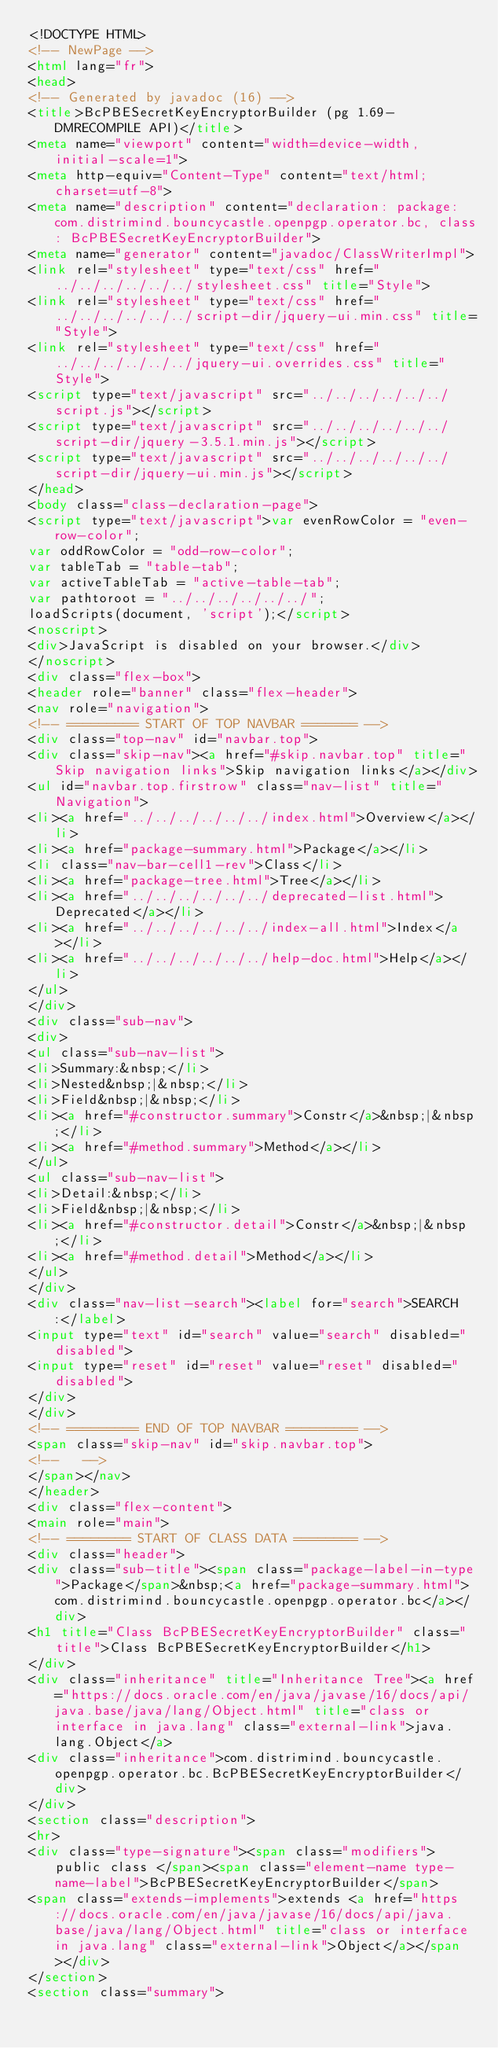<code> <loc_0><loc_0><loc_500><loc_500><_HTML_><!DOCTYPE HTML>
<!-- NewPage -->
<html lang="fr">
<head>
<!-- Generated by javadoc (16) -->
<title>BcPBESecretKeyEncryptorBuilder (pg 1.69-DMRECOMPILE API)</title>
<meta name="viewport" content="width=device-width, initial-scale=1">
<meta http-equiv="Content-Type" content="text/html; charset=utf-8">
<meta name="description" content="declaration: package: com.distrimind.bouncycastle.openpgp.operator.bc, class: BcPBESecretKeyEncryptorBuilder">
<meta name="generator" content="javadoc/ClassWriterImpl">
<link rel="stylesheet" type="text/css" href="../../../../../../stylesheet.css" title="Style">
<link rel="stylesheet" type="text/css" href="../../../../../../script-dir/jquery-ui.min.css" title="Style">
<link rel="stylesheet" type="text/css" href="../../../../../../jquery-ui.overrides.css" title="Style">
<script type="text/javascript" src="../../../../../../script.js"></script>
<script type="text/javascript" src="../../../../../../script-dir/jquery-3.5.1.min.js"></script>
<script type="text/javascript" src="../../../../../../script-dir/jquery-ui.min.js"></script>
</head>
<body class="class-declaration-page">
<script type="text/javascript">var evenRowColor = "even-row-color";
var oddRowColor = "odd-row-color";
var tableTab = "table-tab";
var activeTableTab = "active-table-tab";
var pathtoroot = "../../../../../../";
loadScripts(document, 'script');</script>
<noscript>
<div>JavaScript is disabled on your browser.</div>
</noscript>
<div class="flex-box">
<header role="banner" class="flex-header">
<nav role="navigation">
<!-- ========= START OF TOP NAVBAR ======= -->
<div class="top-nav" id="navbar.top">
<div class="skip-nav"><a href="#skip.navbar.top" title="Skip navigation links">Skip navigation links</a></div>
<ul id="navbar.top.firstrow" class="nav-list" title="Navigation">
<li><a href="../../../../../../index.html">Overview</a></li>
<li><a href="package-summary.html">Package</a></li>
<li class="nav-bar-cell1-rev">Class</li>
<li><a href="package-tree.html">Tree</a></li>
<li><a href="../../../../../../deprecated-list.html">Deprecated</a></li>
<li><a href="../../../../../../index-all.html">Index</a></li>
<li><a href="../../../../../../help-doc.html">Help</a></li>
</ul>
</div>
<div class="sub-nav">
<div>
<ul class="sub-nav-list">
<li>Summary:&nbsp;</li>
<li>Nested&nbsp;|&nbsp;</li>
<li>Field&nbsp;|&nbsp;</li>
<li><a href="#constructor.summary">Constr</a>&nbsp;|&nbsp;</li>
<li><a href="#method.summary">Method</a></li>
</ul>
<ul class="sub-nav-list">
<li>Detail:&nbsp;</li>
<li>Field&nbsp;|&nbsp;</li>
<li><a href="#constructor.detail">Constr</a>&nbsp;|&nbsp;</li>
<li><a href="#method.detail">Method</a></li>
</ul>
</div>
<div class="nav-list-search"><label for="search">SEARCH:</label>
<input type="text" id="search" value="search" disabled="disabled">
<input type="reset" id="reset" value="reset" disabled="disabled">
</div>
</div>
<!-- ========= END OF TOP NAVBAR ========= -->
<span class="skip-nav" id="skip.navbar.top">
<!--   -->
</span></nav>
</header>
<div class="flex-content">
<main role="main">
<!-- ======== START OF CLASS DATA ======== -->
<div class="header">
<div class="sub-title"><span class="package-label-in-type">Package</span>&nbsp;<a href="package-summary.html">com.distrimind.bouncycastle.openpgp.operator.bc</a></div>
<h1 title="Class BcPBESecretKeyEncryptorBuilder" class="title">Class BcPBESecretKeyEncryptorBuilder</h1>
</div>
<div class="inheritance" title="Inheritance Tree"><a href="https://docs.oracle.com/en/java/javase/16/docs/api/java.base/java/lang/Object.html" title="class or interface in java.lang" class="external-link">java.lang.Object</a>
<div class="inheritance">com.distrimind.bouncycastle.openpgp.operator.bc.BcPBESecretKeyEncryptorBuilder</div>
</div>
<section class="description">
<hr>
<div class="type-signature"><span class="modifiers">public class </span><span class="element-name type-name-label">BcPBESecretKeyEncryptorBuilder</span>
<span class="extends-implements">extends <a href="https://docs.oracle.com/en/java/javase/16/docs/api/java.base/java/lang/Object.html" title="class or interface in java.lang" class="external-link">Object</a></span></div>
</section>
<section class="summary"></code> 